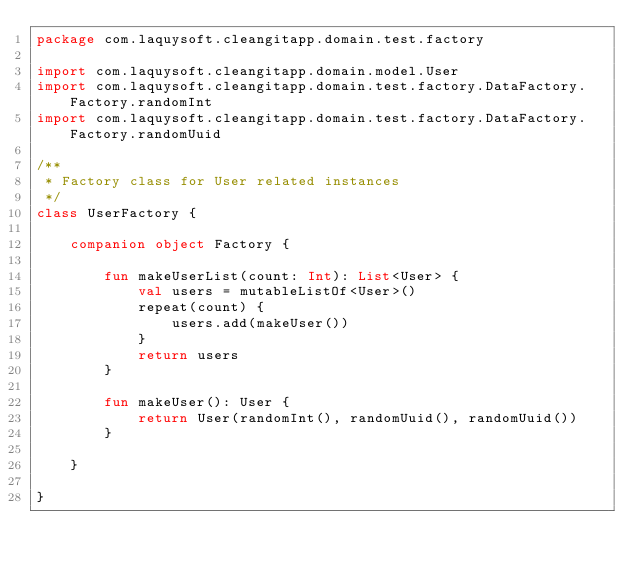Convert code to text. <code><loc_0><loc_0><loc_500><loc_500><_Kotlin_>package com.laquysoft.cleangitapp.domain.test.factory

import com.laquysoft.cleangitapp.domain.model.User
import com.laquysoft.cleangitapp.domain.test.factory.DataFactory.Factory.randomInt
import com.laquysoft.cleangitapp.domain.test.factory.DataFactory.Factory.randomUuid

/**
 * Factory class for User related instances
 */
class UserFactory {

    companion object Factory {

        fun makeUserList(count: Int): List<User> {
            val users = mutableListOf<User>()
            repeat(count) {
                users.add(makeUser())
            }
            return users
        }

        fun makeUser(): User {
            return User(randomInt(), randomUuid(), randomUuid())
        }

    }

}
</code> 